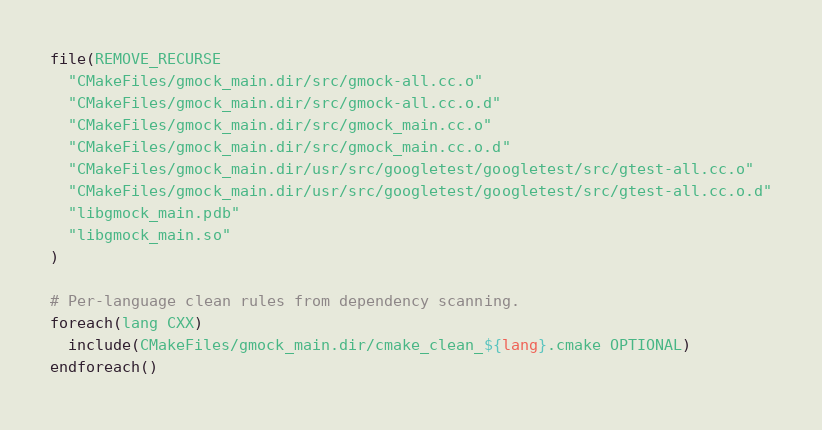<code> <loc_0><loc_0><loc_500><loc_500><_CMake_>file(REMOVE_RECURSE
  "CMakeFiles/gmock_main.dir/src/gmock-all.cc.o"
  "CMakeFiles/gmock_main.dir/src/gmock-all.cc.o.d"
  "CMakeFiles/gmock_main.dir/src/gmock_main.cc.o"
  "CMakeFiles/gmock_main.dir/src/gmock_main.cc.o.d"
  "CMakeFiles/gmock_main.dir/usr/src/googletest/googletest/src/gtest-all.cc.o"
  "CMakeFiles/gmock_main.dir/usr/src/googletest/googletest/src/gtest-all.cc.o.d"
  "libgmock_main.pdb"
  "libgmock_main.so"
)

# Per-language clean rules from dependency scanning.
foreach(lang CXX)
  include(CMakeFiles/gmock_main.dir/cmake_clean_${lang}.cmake OPTIONAL)
endforeach()
</code> 